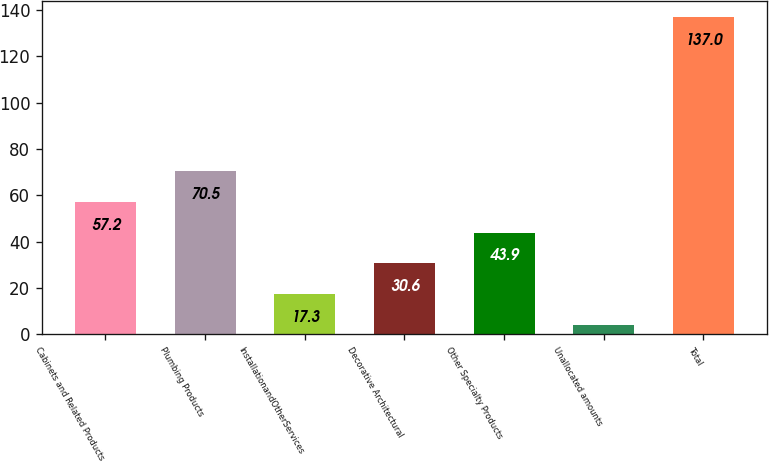<chart> <loc_0><loc_0><loc_500><loc_500><bar_chart><fcel>Cabinets and Related Products<fcel>Plumbing Products<fcel>InstallationandOtherServices<fcel>Decorative Architectural<fcel>Other Specialty Products<fcel>Unallocated amounts<fcel>Total<nl><fcel>57.2<fcel>70.5<fcel>17.3<fcel>30.6<fcel>43.9<fcel>4<fcel>137<nl></chart> 